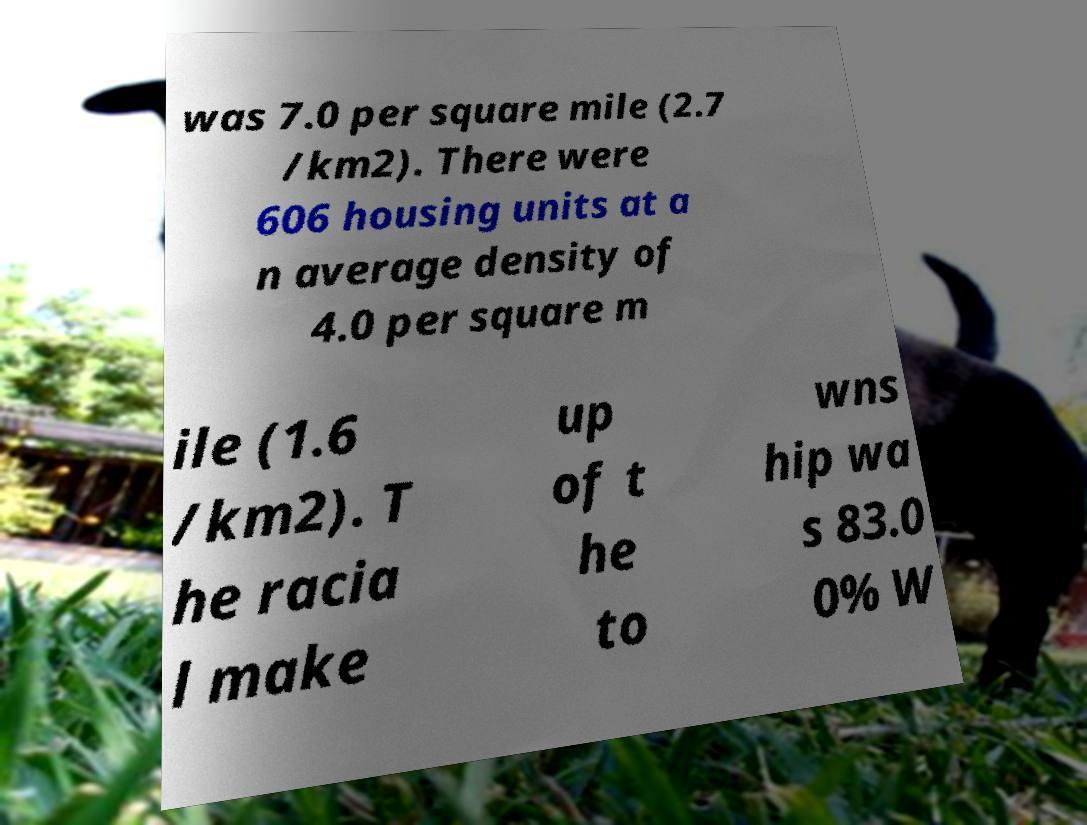I need the written content from this picture converted into text. Can you do that? was 7.0 per square mile (2.7 /km2). There were 606 housing units at a n average density of 4.0 per square m ile (1.6 /km2). T he racia l make up of t he to wns hip wa s 83.0 0% W 